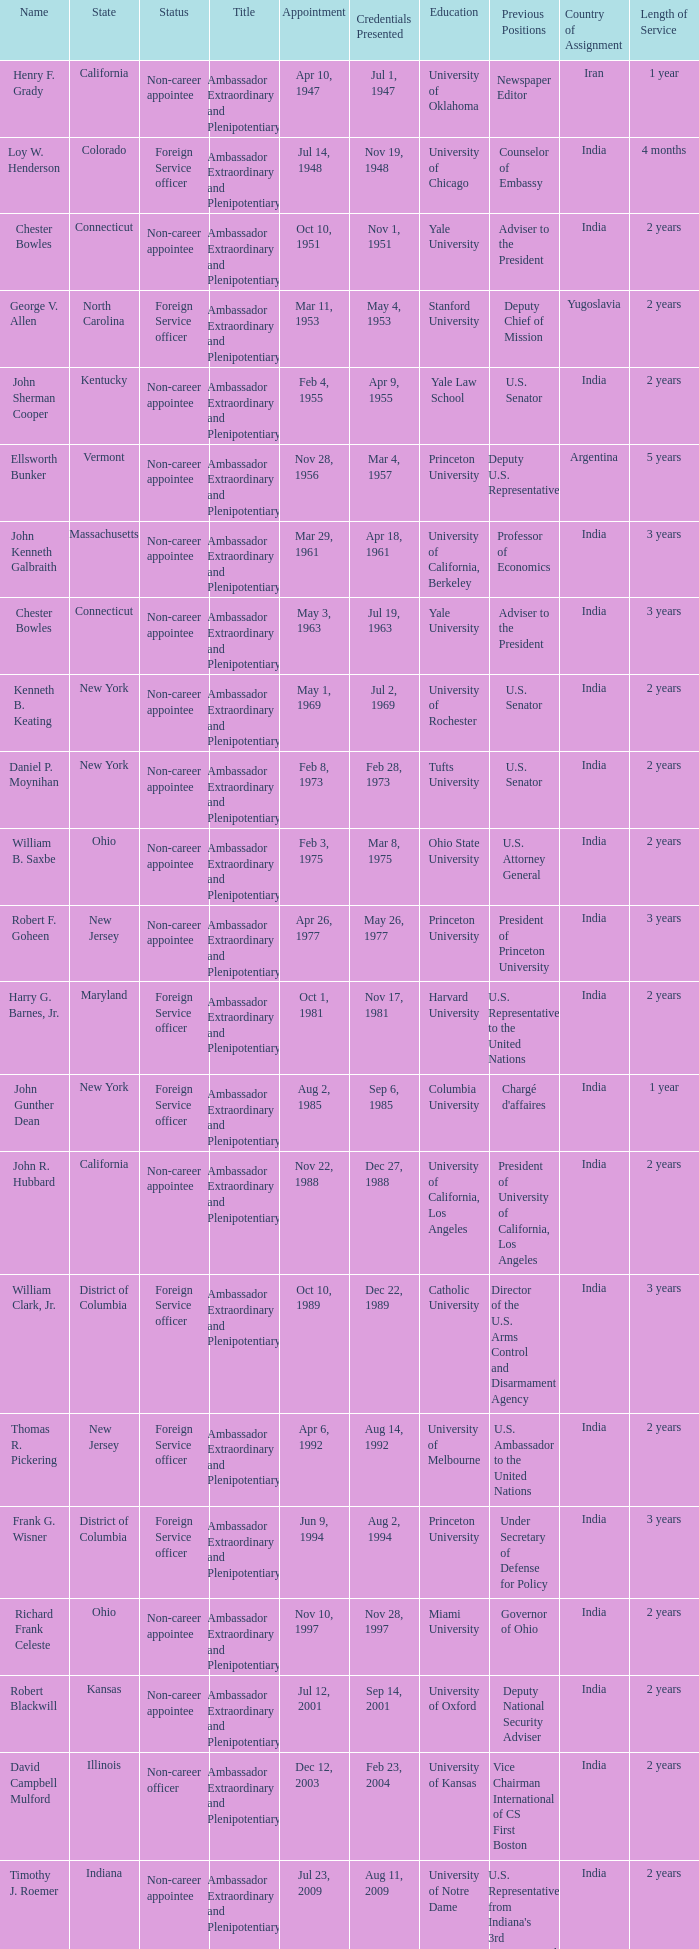What is the title for david campbell mulford? Ambassador Extraordinary and Plenipotentiary. 